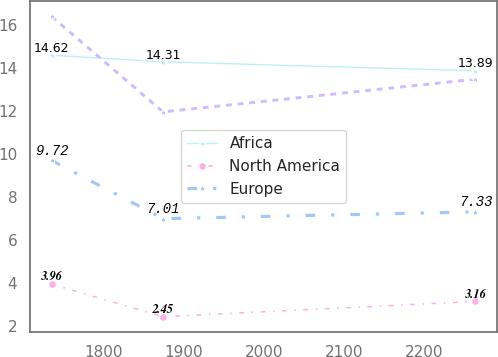<chart> <loc_0><loc_0><loc_500><loc_500><line_chart><ecel><fcel>Africa<fcel>North America<fcel>Europe<fcel>Unnamed: 4<nl><fcel>1735.04<fcel>14.62<fcel>3.96<fcel>9.72<fcel>16.42<nl><fcel>1874.07<fcel>14.31<fcel>2.45<fcel>7.01<fcel>11.98<nl><fcel>2263.8<fcel>13.89<fcel>3.16<fcel>7.33<fcel>13.5<nl></chart> 